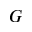<formula> <loc_0><loc_0><loc_500><loc_500>G</formula> 